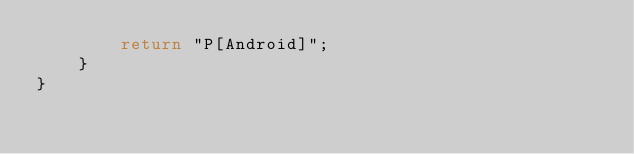Convert code to text. <code><loc_0><loc_0><loc_500><loc_500><_Java_>        return "P[Android]";
    }
}
</code> 